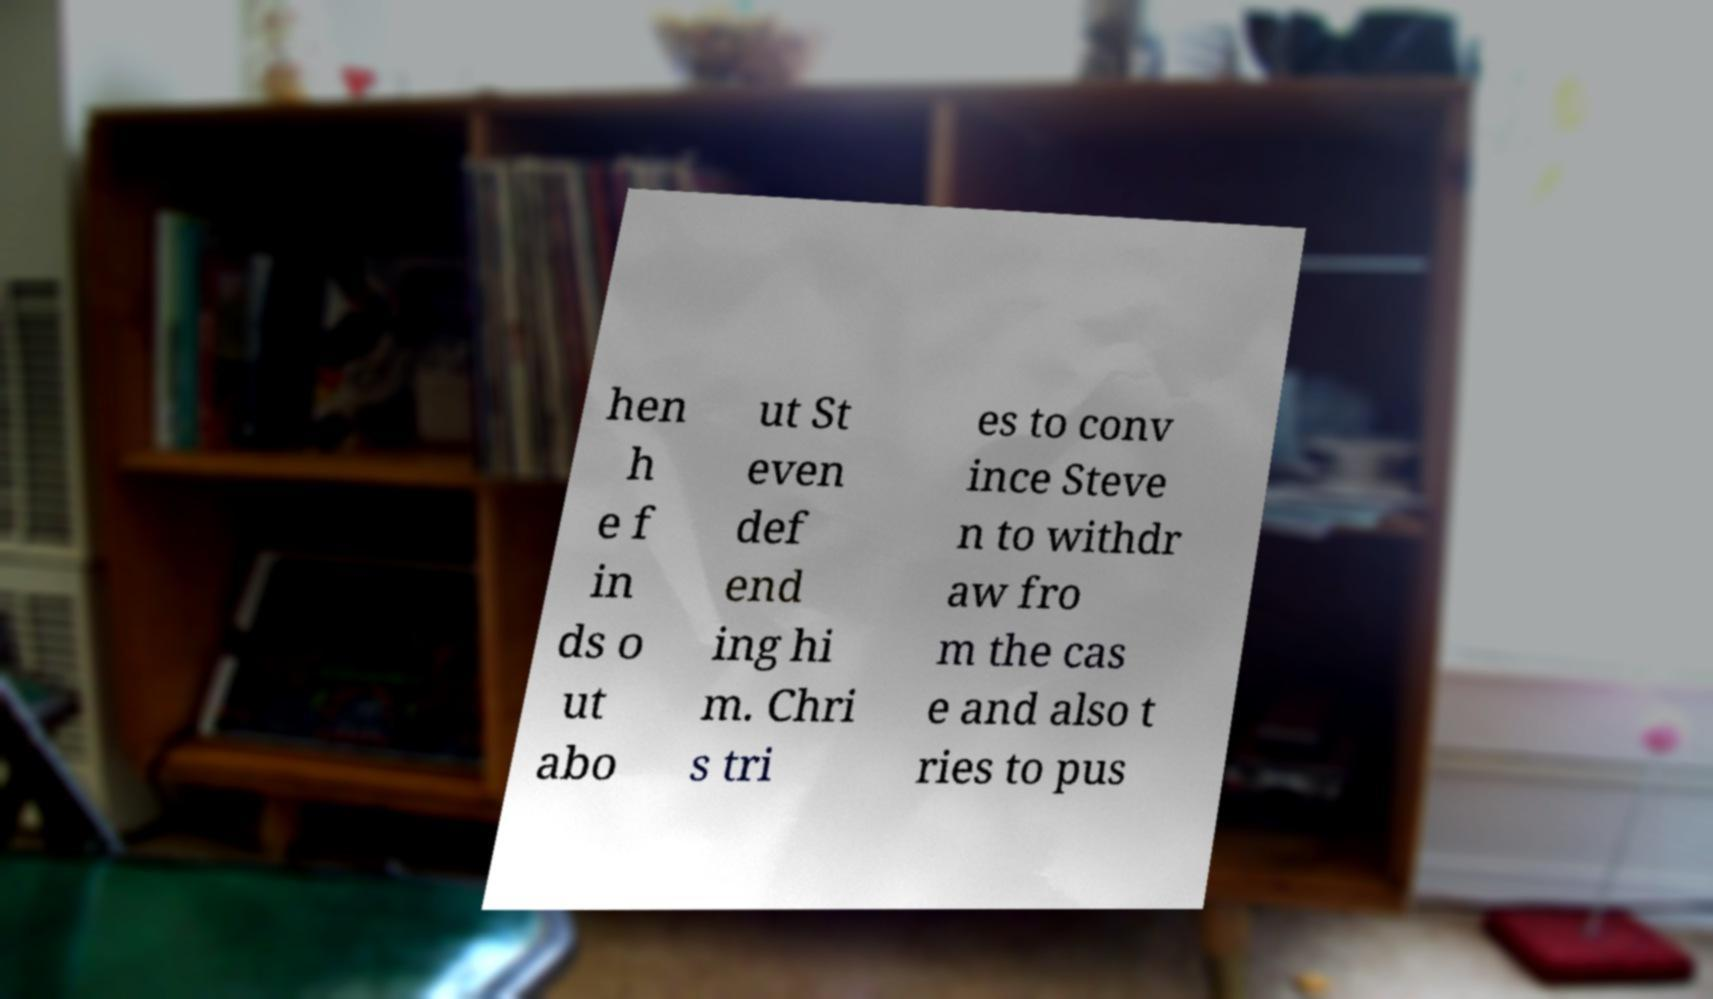For documentation purposes, I need the text within this image transcribed. Could you provide that? hen h e f in ds o ut abo ut St even def end ing hi m. Chri s tri es to conv ince Steve n to withdr aw fro m the cas e and also t ries to pus 